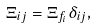Convert formula to latex. <formula><loc_0><loc_0><loc_500><loc_500>\Xi _ { i j } = \Xi _ { f _ { i } } \delta _ { i j } ,</formula> 